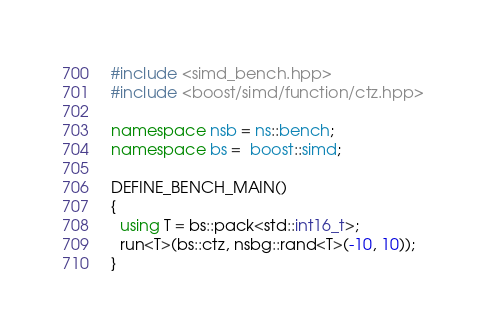<code> <loc_0><loc_0><loc_500><loc_500><_C++_>#include <simd_bench.hpp>
#include <boost/simd/function/ctz.hpp>

namespace nsb = ns::bench;
namespace bs =  boost::simd;

DEFINE_BENCH_MAIN()
{
  using T = bs::pack<std::int16_t>;
  run<T>(bs::ctz, nsbg::rand<T>(-10, 10));
}

</code> 